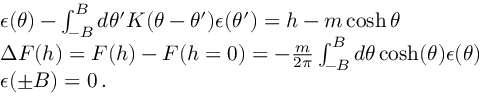Convert formula to latex. <formula><loc_0><loc_0><loc_500><loc_500>\begin{array} { r l } & { \epsilon ( \theta ) - \int _ { - B } ^ { B } d \theta ^ { \prime } K ( \theta - \theta ^ { \prime } ) \epsilon ( \theta ^ { \prime } ) = h - m \cosh \theta } \\ & { \Delta F ( h ) = F ( h ) - F ( h = 0 ) = - \frac { m } { 2 \pi } \int _ { - B } ^ { B } d \theta \cosh ( \theta ) \epsilon ( \theta ) } \\ & { \epsilon ( \pm B ) = 0 \, . } \end{array}</formula> 